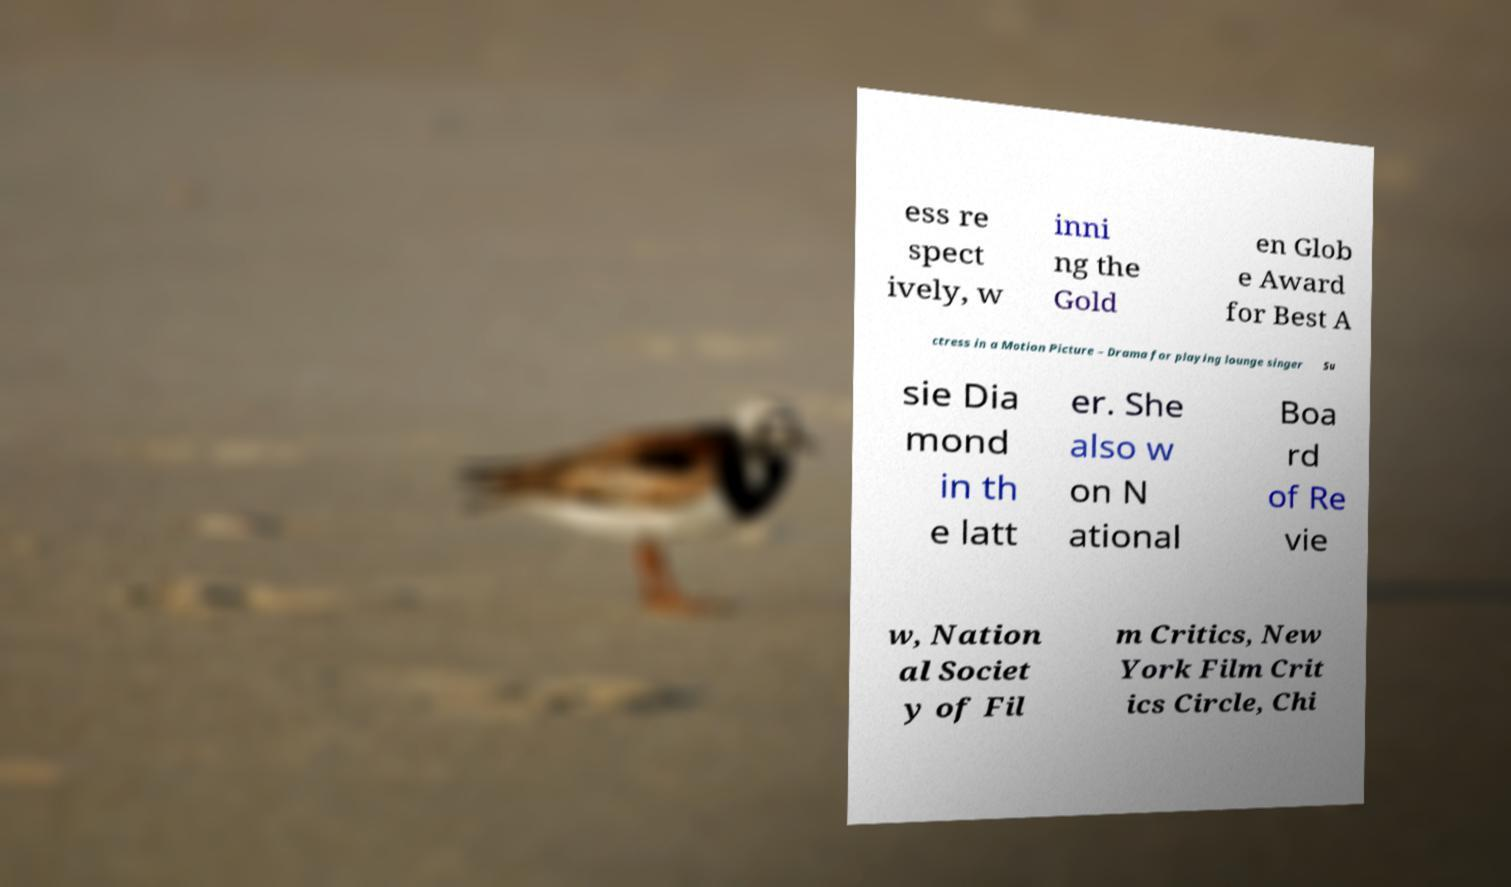Can you read and provide the text displayed in the image?This photo seems to have some interesting text. Can you extract and type it out for me? ess re spect ively, w inni ng the Gold en Glob e Award for Best A ctress in a Motion Picture – Drama for playing lounge singer Su sie Dia mond in th e latt er. She also w on N ational Boa rd of Re vie w, Nation al Societ y of Fil m Critics, New York Film Crit ics Circle, Chi 